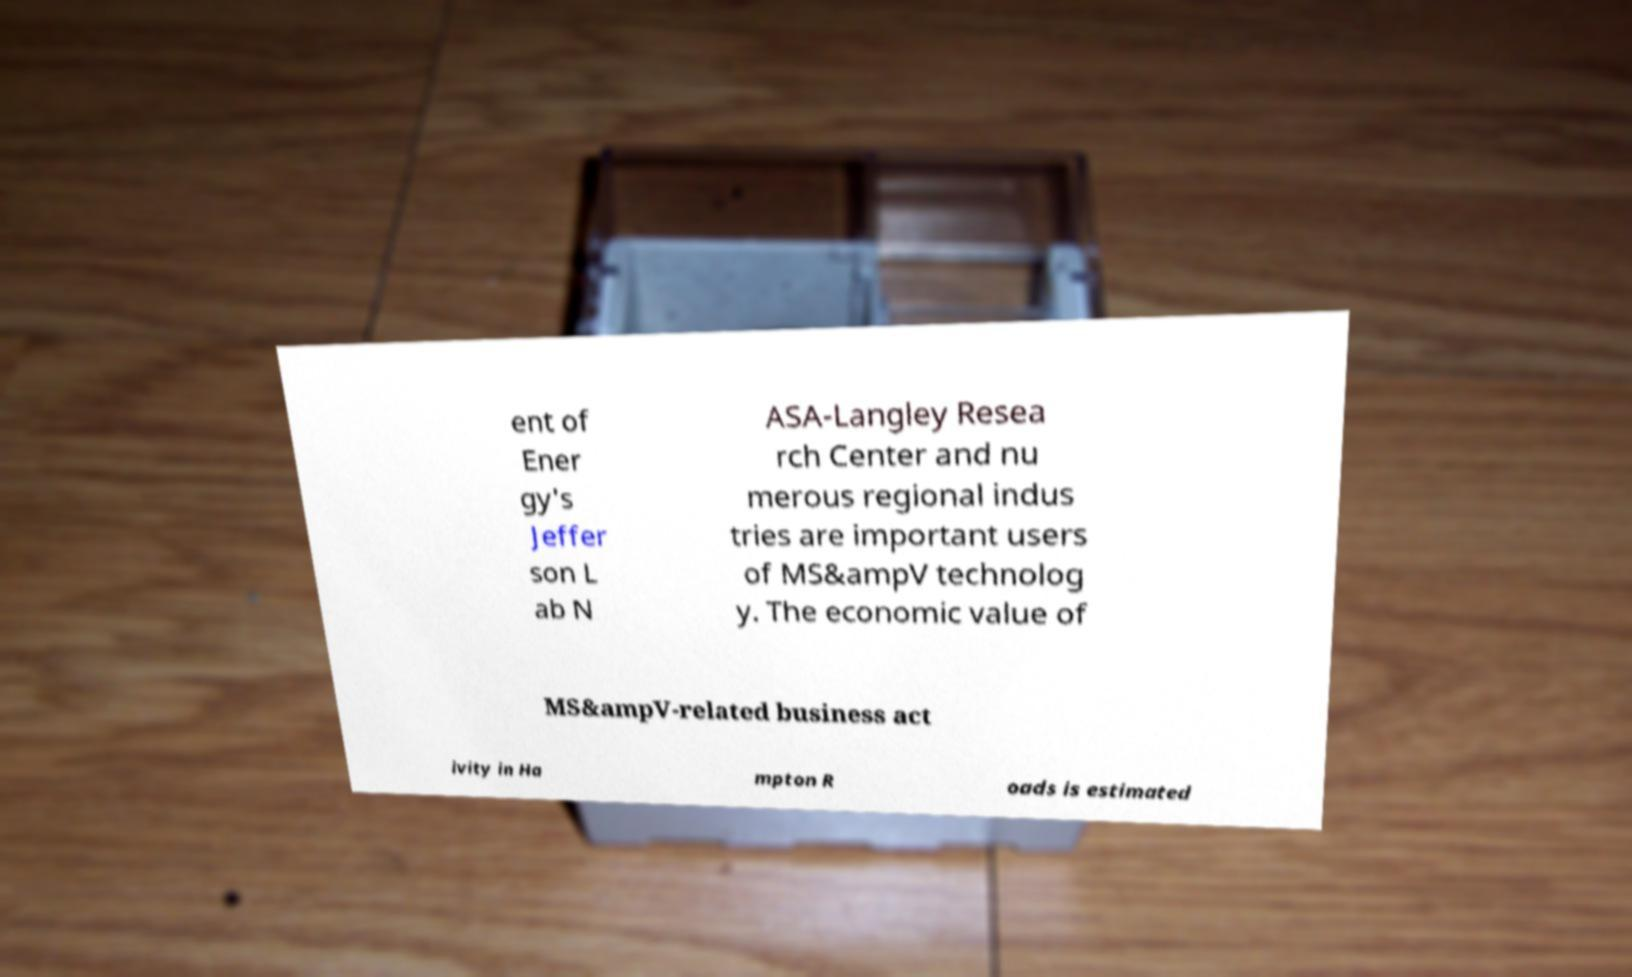Can you accurately transcribe the text from the provided image for me? ent of Ener gy's Jeffer son L ab N ASA-Langley Resea rch Center and nu merous regional indus tries are important users of MS&ampV technolog y. The economic value of MS&ampV-related business act ivity in Ha mpton R oads is estimated 